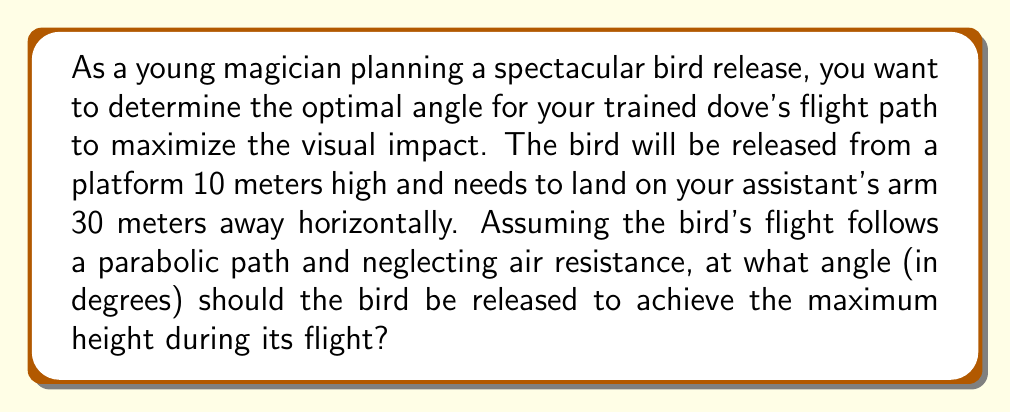Show me your answer to this math problem. Let's approach this step-by-step:

1) The bird's flight path can be modeled using the equation of a projectile motion:

   $$y = -\frac{g}{2v_0^2\cos^2\theta}x^2 + x\tan\theta + h$$

   Where $g$ is acceleration due to gravity (9.8 m/s²), $v_0$ is initial velocity, $\theta$ is the launch angle, $h$ is the initial height, and $(x,y)$ are the coordinates.

2) We know the initial height $h = 10$ m and the horizontal distance $x = 30$ m.

3) To find the angle that gives the maximum height, we need to use the fact that for a parabolic path, the maximum height occurs when the horizontal distance is half of the total distance.

4) So, we can set up the equation:

   $$10 = -\frac{9.8}{2v_0^2\cos^2\theta}(15)^2 + 15\tan\theta + 10$$

5) Simplify:

   $$0 = -\frac{1102.5}{v_0^2\cos^2\theta} + 15\tan\theta$$

6) Divide both sides by 15:

   $$0 = -\frac{73.5}{v_0^2\cos^2\theta} + \tan\theta$$

7) We know that $\tan\theta = \frac{\sin\theta}{\cos\theta}$, so:

   $$\frac{73.5}{v_0^2\cos^2\theta} = \frac{\sin\theta}{\cos\theta}$$

8) Simplify:

   $$\frac{73.5}{v_0^2} = \sin\theta\cos\theta = \frac{1}{2}\sin(2\theta)$$

9) The maximum value of $\sin(2\theta)$ is 1, which occurs when $2\theta = 90°$ or $\theta = 45°$.

Therefore, the optimal angle for the bird's release is 45°.
Answer: The optimal angle for the bird's flight path is 45°. 